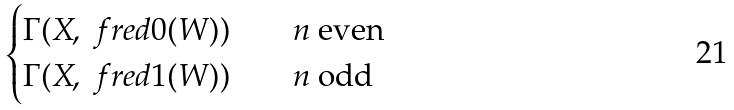Convert formula to latex. <formula><loc_0><loc_0><loc_500><loc_500>\begin{cases} \Gamma ( X , \ f r e d { 0 } ( W ) ) & \quad \text {$n$ even} \\ \Gamma ( X , \ f r e d { 1 } ( W ) ) & \quad \text {$n$ odd} \\ \end{cases}</formula> 